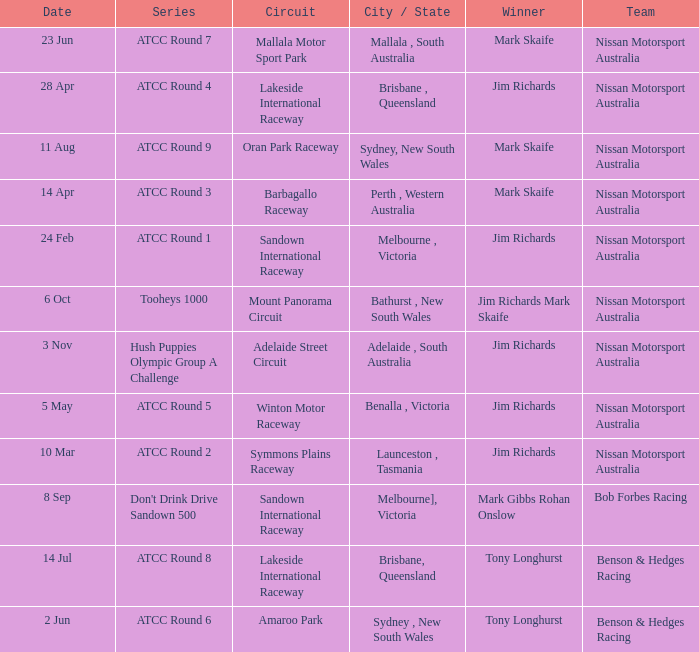What is the circuit in the atcc round 1 series with conqueror jim richards? Sandown International Raceway. 